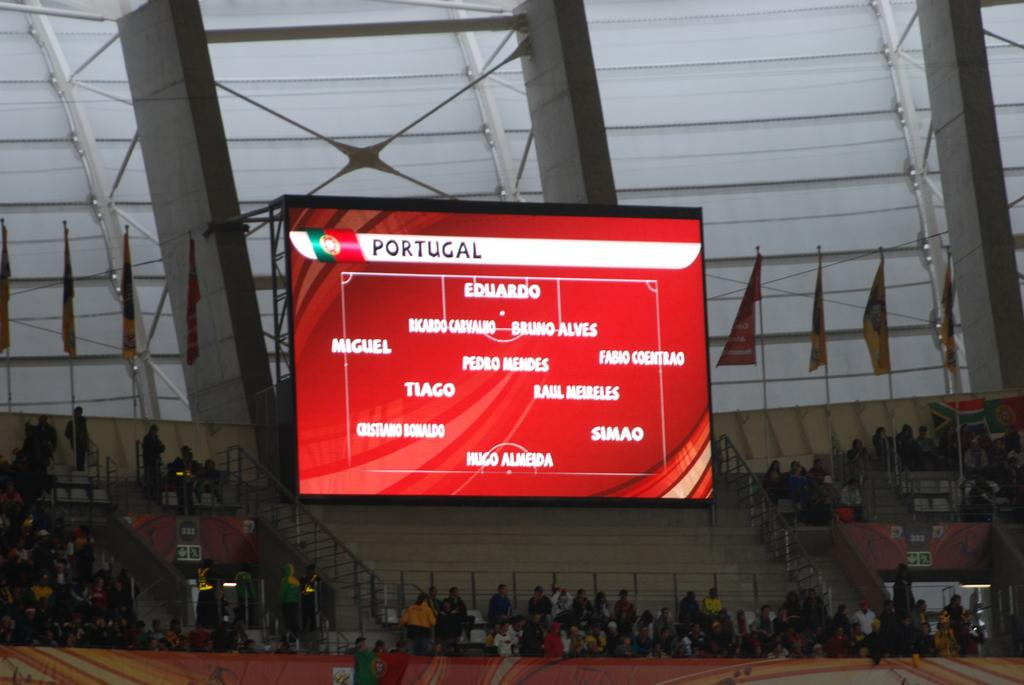<image>
Offer a succinct explanation of the picture presented. Stadium jumbo tron screen with Portugal players listed, beginning with Eduardo. 